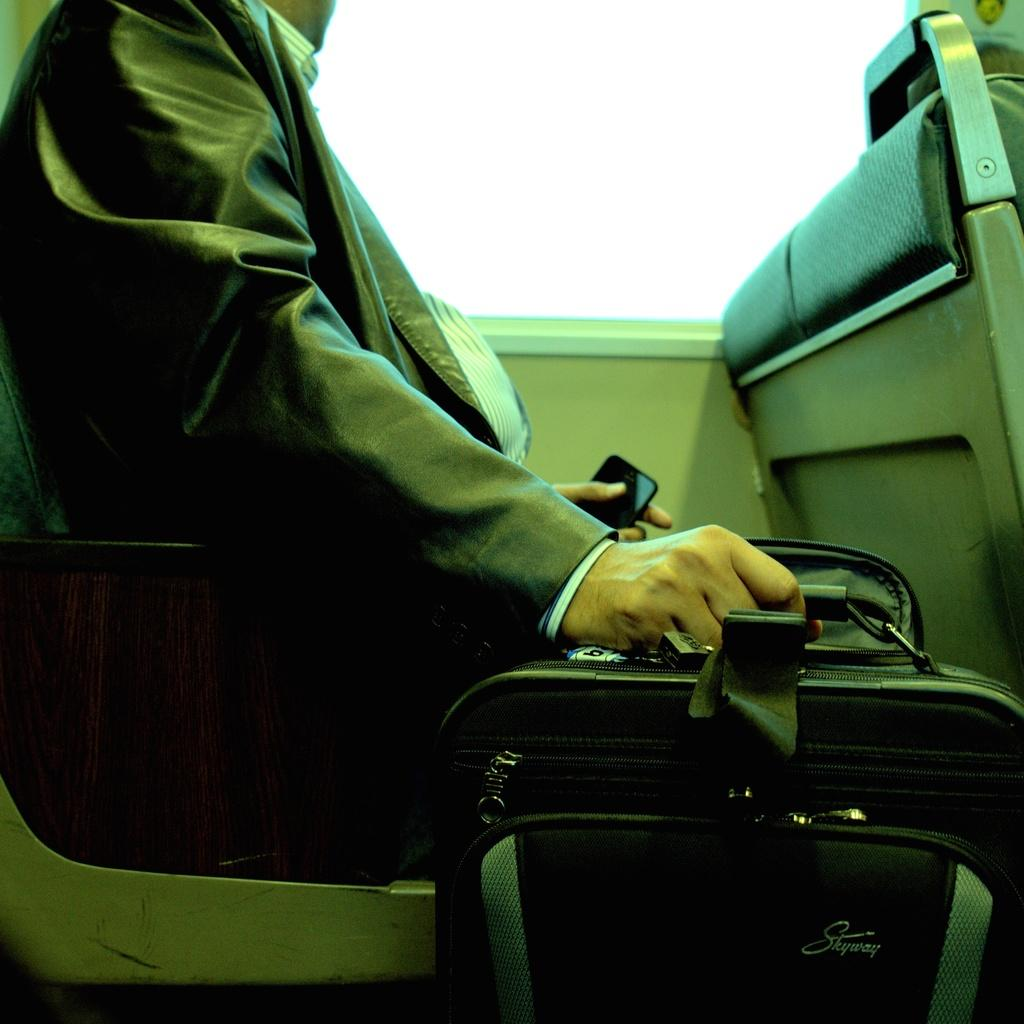Who is present in the image? There is a man in the image. What is the man doing in the image? The man is sitting on a chair. What is the man holding in one hand? The man is holding a bag in one hand. What is the man holding in the other hand? The man is holding a mobile in the other hand. Is the man in the image a fireman? There is no indication in the image that the man is a fireman. Is the man in the image holding a chain? There is no chain visible in the image. 